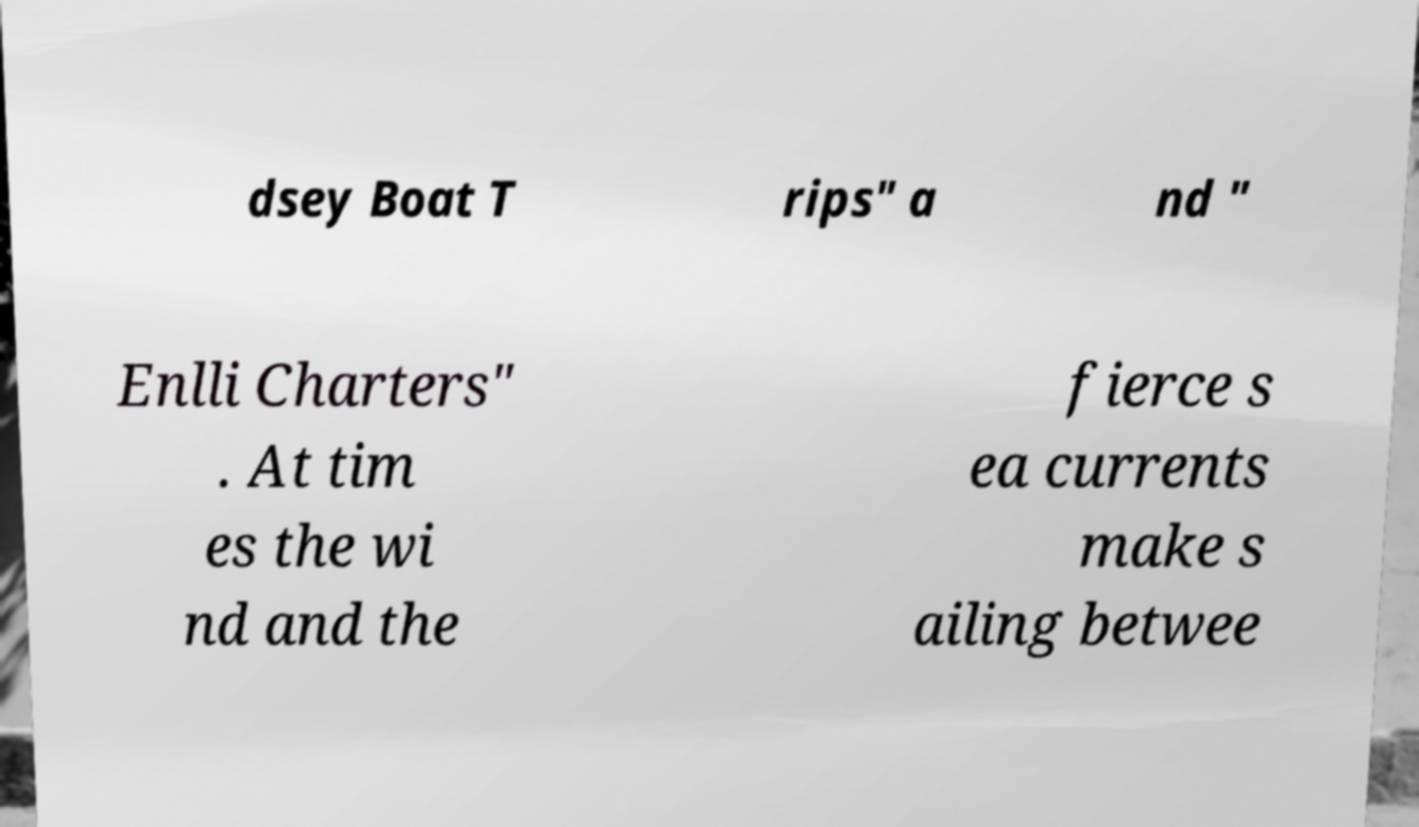Please read and relay the text visible in this image. What does it say? dsey Boat T rips" a nd " Enlli Charters" . At tim es the wi nd and the fierce s ea currents make s ailing betwee 